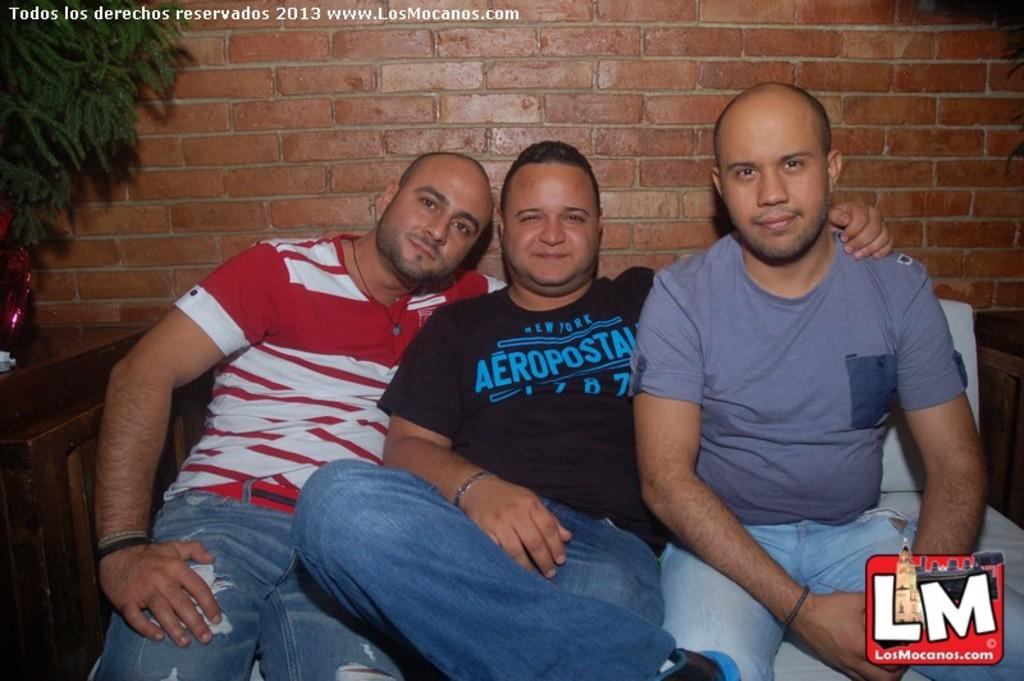How many people are sitting in the image? There are three people sitting in the image. What can be seen in the background of the image? There is a brick wall in the background of the image. What is present on the table in the image? There is a tree on the table in the image. What type of marks are visible in the image? There are watermarks visible in the image. What type of cord is being used by the people in the image? There is no cord visible in the image; the people are simply sitting. 